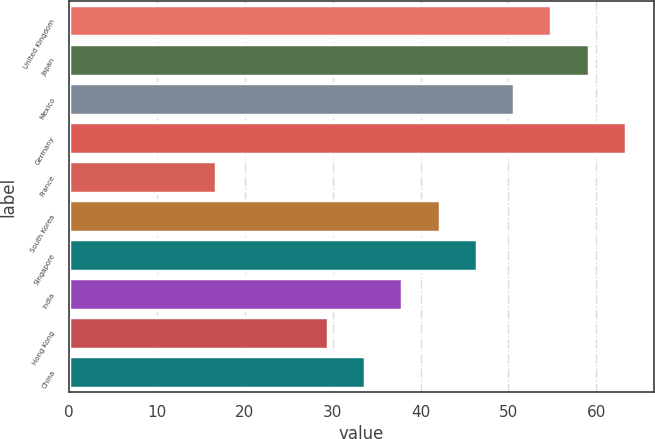Convert chart to OTSL. <chart><loc_0><loc_0><loc_500><loc_500><bar_chart><fcel>United Kingdom<fcel>Japan<fcel>Mexico<fcel>Germany<fcel>France<fcel>South Korea<fcel>Singapore<fcel>India<fcel>Hong Kong<fcel>China<nl><fcel>54.88<fcel>59.12<fcel>50.64<fcel>63.36<fcel>16.72<fcel>42.16<fcel>46.4<fcel>37.92<fcel>29.44<fcel>33.68<nl></chart> 